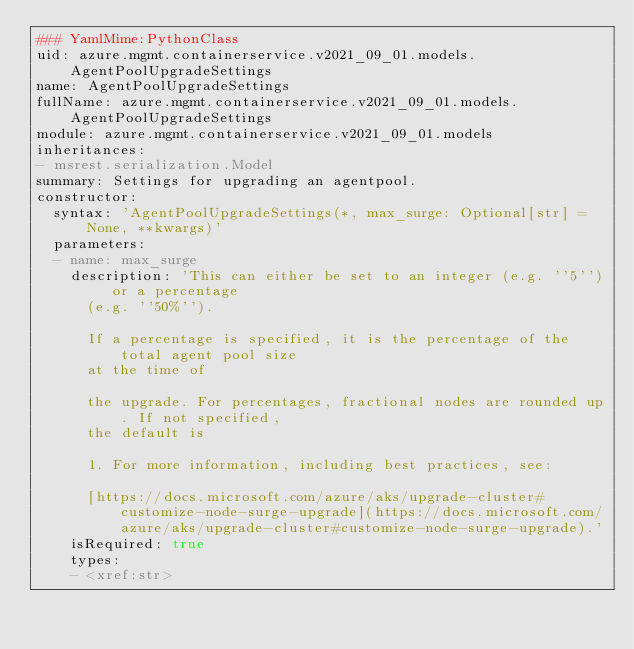<code> <loc_0><loc_0><loc_500><loc_500><_YAML_>### YamlMime:PythonClass
uid: azure.mgmt.containerservice.v2021_09_01.models.AgentPoolUpgradeSettings
name: AgentPoolUpgradeSettings
fullName: azure.mgmt.containerservice.v2021_09_01.models.AgentPoolUpgradeSettings
module: azure.mgmt.containerservice.v2021_09_01.models
inheritances:
- msrest.serialization.Model
summary: Settings for upgrading an agentpool.
constructor:
  syntax: 'AgentPoolUpgradeSettings(*, max_surge: Optional[str] = None, **kwargs)'
  parameters:
  - name: max_surge
    description: 'This can either be set to an integer (e.g. ''5'') or a percentage
      (e.g. ''50%'').

      If a percentage is specified, it is the percentage of the total agent pool size
      at the time of

      the upgrade. For percentages, fractional nodes are rounded up. If not specified,
      the default is

      1. For more information, including best practices, see:

      [https://docs.microsoft.com/azure/aks/upgrade-cluster#customize-node-surge-upgrade](https://docs.microsoft.com/azure/aks/upgrade-cluster#customize-node-surge-upgrade).'
    isRequired: true
    types:
    - <xref:str>
</code> 